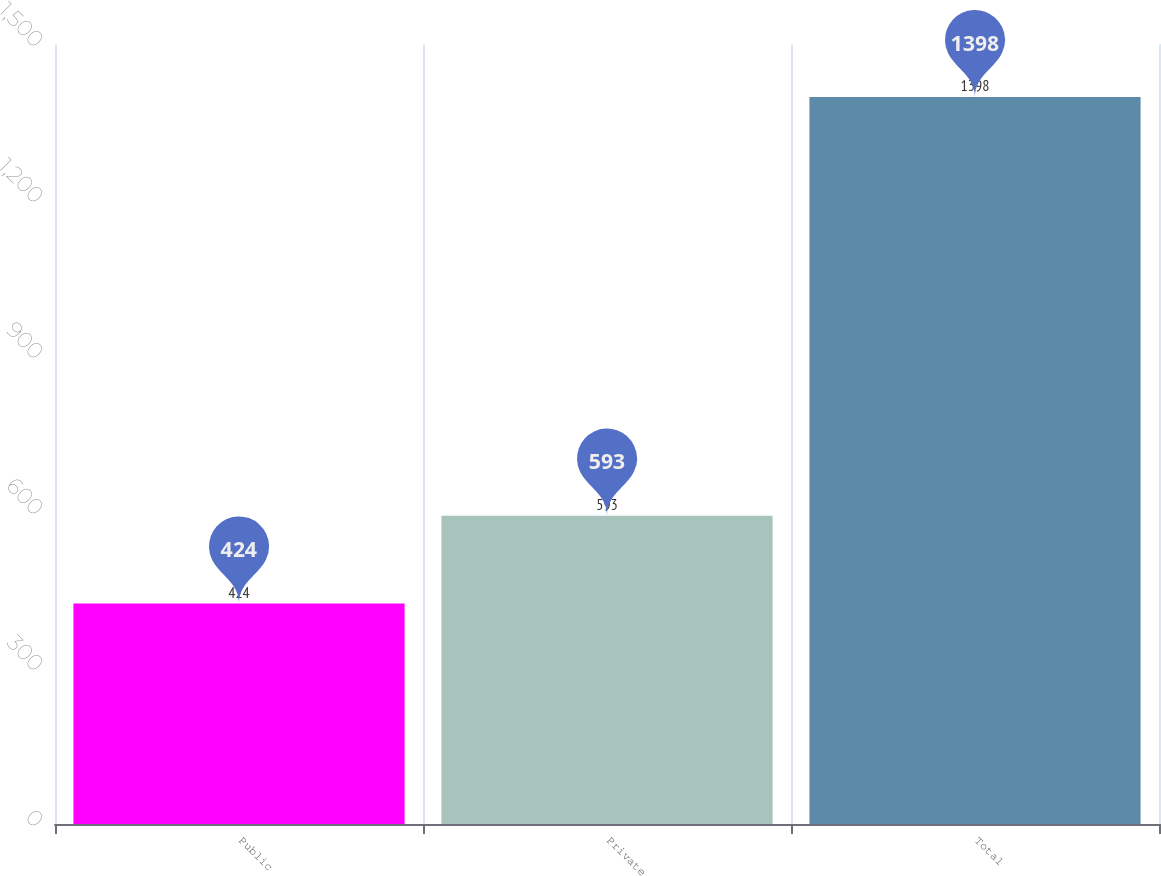<chart> <loc_0><loc_0><loc_500><loc_500><bar_chart><fcel>Public<fcel>Private<fcel>Total<nl><fcel>424<fcel>593<fcel>1398<nl></chart> 